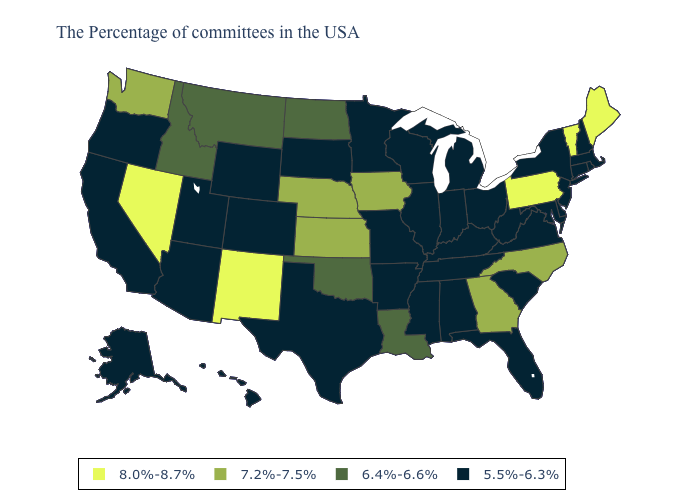What is the highest value in the USA?
Be succinct. 8.0%-8.7%. Does Georgia have the highest value in the South?
Concise answer only. Yes. Name the states that have a value in the range 5.5%-6.3%?
Answer briefly. Massachusetts, Rhode Island, New Hampshire, Connecticut, New York, New Jersey, Delaware, Maryland, Virginia, South Carolina, West Virginia, Ohio, Florida, Michigan, Kentucky, Indiana, Alabama, Tennessee, Wisconsin, Illinois, Mississippi, Missouri, Arkansas, Minnesota, Texas, South Dakota, Wyoming, Colorado, Utah, Arizona, California, Oregon, Alaska, Hawaii. What is the lowest value in states that border Arkansas?
Give a very brief answer. 5.5%-6.3%. Among the states that border Louisiana , which have the lowest value?
Write a very short answer. Mississippi, Arkansas, Texas. What is the value of New Mexico?
Write a very short answer. 8.0%-8.7%. Name the states that have a value in the range 8.0%-8.7%?
Answer briefly. Maine, Vermont, Pennsylvania, New Mexico, Nevada. Does Idaho have a higher value than Vermont?
Give a very brief answer. No. What is the lowest value in the USA?
Write a very short answer. 5.5%-6.3%. What is the lowest value in the USA?
Quick response, please. 5.5%-6.3%. Among the states that border Wisconsin , does Iowa have the highest value?
Answer briefly. Yes. What is the lowest value in states that border Idaho?
Keep it brief. 5.5%-6.3%. Among the states that border Colorado , which have the lowest value?
Keep it brief. Wyoming, Utah, Arizona. Does the map have missing data?
Concise answer only. No. Name the states that have a value in the range 6.4%-6.6%?
Give a very brief answer. Louisiana, Oklahoma, North Dakota, Montana, Idaho. 